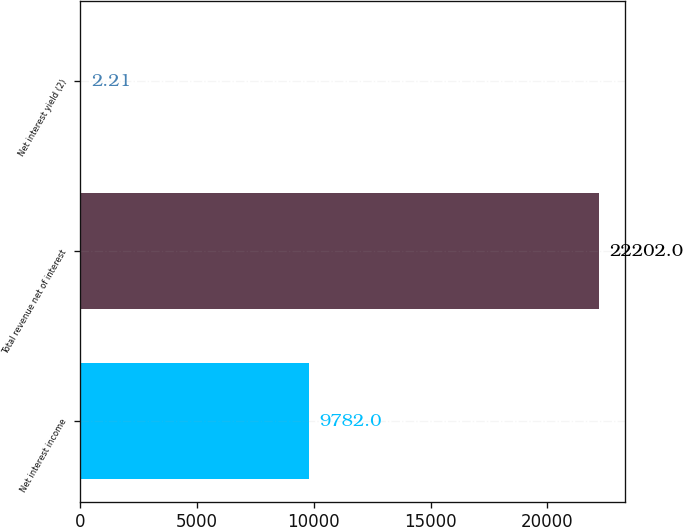Convert chart to OTSL. <chart><loc_0><loc_0><loc_500><loc_500><bar_chart><fcel>Net interest income<fcel>Total revenue net of interest<fcel>Net interest yield (2)<nl><fcel>9782<fcel>22202<fcel>2.21<nl></chart> 